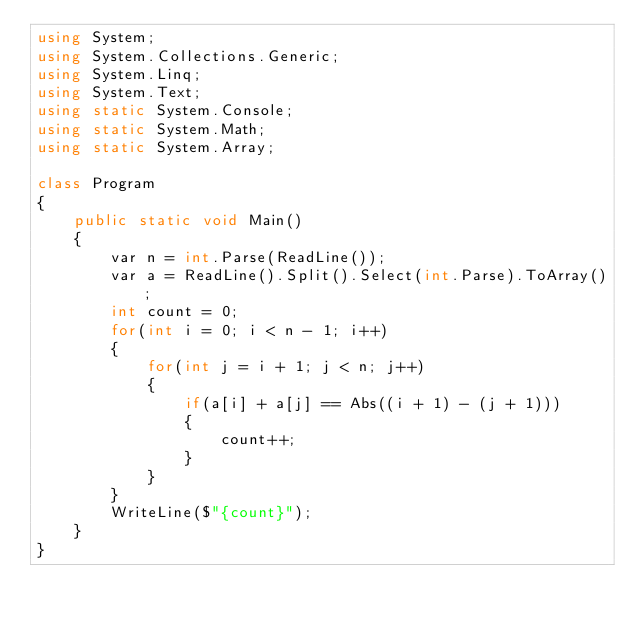Convert code to text. <code><loc_0><loc_0><loc_500><loc_500><_C#_>using System;
using System.Collections.Generic;
using System.Linq;
using System.Text;
using static System.Console;
using static System.Math;
using static System.Array;

class Program
{
    public static void Main()
    {
        var n = int.Parse(ReadLine());
        var a = ReadLine().Split().Select(int.Parse).ToArray();
        int count = 0;
        for(int i = 0; i < n - 1; i++)
        {
            for(int j = i + 1; j < n; j++)
            {
                if(a[i] + a[j] == Abs((i + 1) - (j + 1)))
                {
                    count++;
                }
            }
        }
        WriteLine($"{count}");
    }
}
</code> 